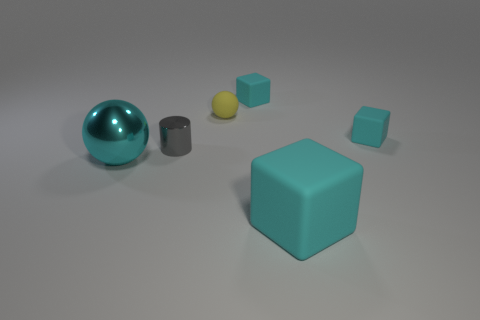Are there any large cubes that have the same material as the yellow sphere?
Your answer should be compact. Yes. Is the number of balls that are behind the gray cylinder greater than the number of small gray metallic cylinders that are behind the tiny yellow rubber sphere?
Provide a short and direct response. Yes. Is the metal cylinder the same size as the yellow matte object?
Make the answer very short. Yes. What is the color of the small rubber cube that is on the left side of the block that is in front of the metallic cylinder?
Your response must be concise. Cyan. What is the color of the big block?
Keep it short and to the point. Cyan. Are there any large rubber cubes that have the same color as the big sphere?
Your answer should be compact. Yes. There is a thing that is in front of the cyan metallic thing; does it have the same color as the big metallic sphere?
Make the answer very short. Yes. How many things are either rubber blocks that are behind the cyan metallic sphere or cyan objects?
Provide a short and direct response. 4. Are there any cyan things on the left side of the large cyan matte object?
Ensure brevity in your answer.  Yes. What material is the big thing that is the same color as the large cube?
Your answer should be very brief. Metal. 